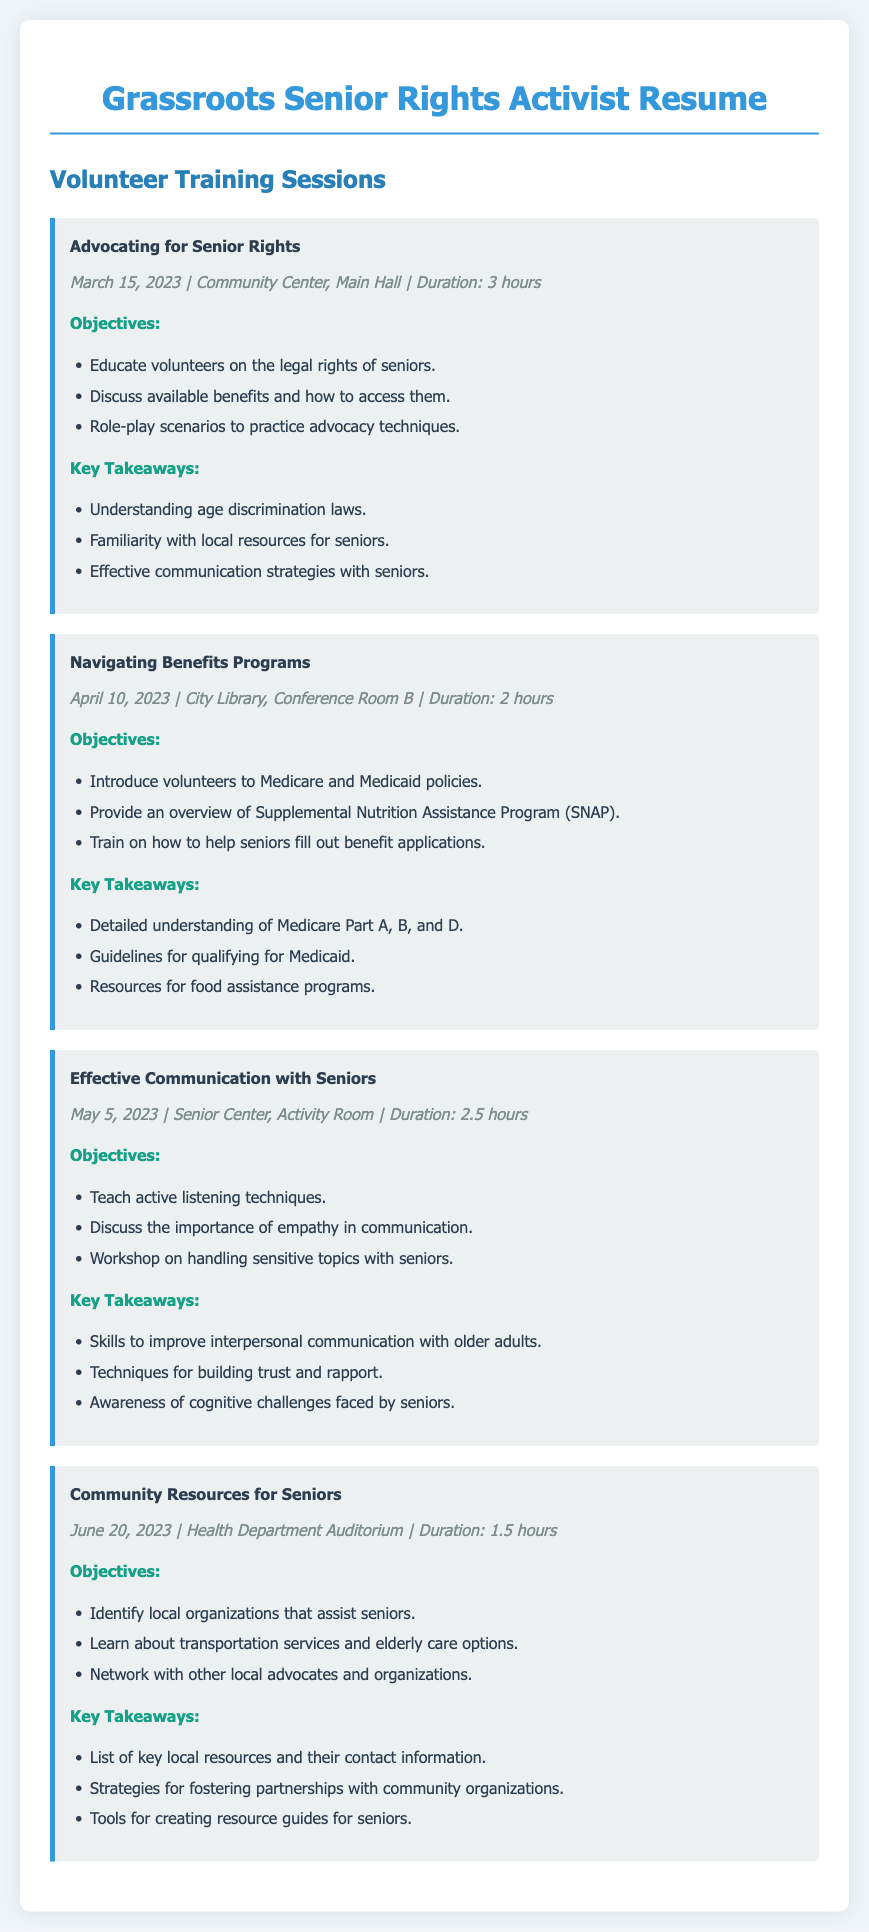What is the title of the first training session? The title of the first training session is found in the document under "session-title" for the first session.
Answer: Advocating for Senior Rights When was the "Navigating Benefits Programs" session held? The date for the "Navigating Benefits Programs" session is provided in the "session-details" section of that particular session.
Answer: April 10, 2023 What is the duration of the "Effective Communication with Seniors" session? The duration can be found in the "session-details" and is listed alongside the date and location of the session.
Answer: 2.5 hours What are the key takeaways for the "Community Resources for Seniors" session? This information is presented in the "Key Takeaways" section under the respective session.
Answer: List of key local resources and their contact information How many objectives are listed for the "Advocating for Senior Rights" session? The number of objectives can be counted from the list provided in the "Objectives" section of that training session.
Answer: 3 What is one key takeaway from the "Navigating Benefits Programs" session? Key takeaways can be found under the "Key Takeaways" section for that specific session.
Answer: Detailed understanding of Medicare Part A, B, and D Which location hosted the "Community Resources for Seniors" training? The location is specified in the "session-details" of that training session.
Answer: Health Department Auditorium What does the "Effective Communication with Seniors" session emphasize? This can be inferred from the objectives listed for the respective session.
Answer: Active listening techniques How many training sessions are listed in the document? The total number of sessions can be counted from the number of visible sections labeled "session."
Answer: 4 